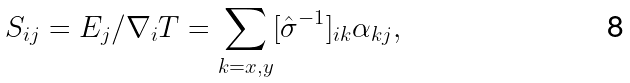Convert formula to latex. <formula><loc_0><loc_0><loc_500><loc_500>S _ { i j } = E _ { j } / \nabla _ { i } T = \sum _ { k = x , y } [ { \hat { \sigma } } ^ { - 1 } ] _ { i k } \alpha _ { k j } ,</formula> 